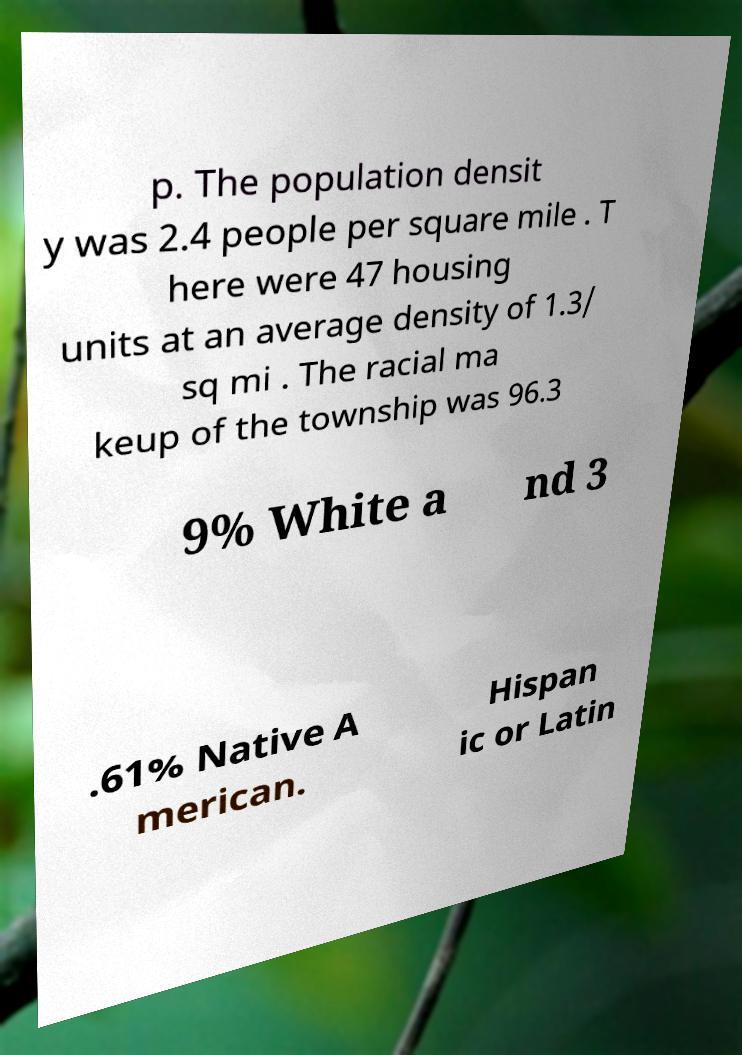Could you extract and type out the text from this image? p. The population densit y was 2.4 people per square mile . T here were 47 housing units at an average density of 1.3/ sq mi . The racial ma keup of the township was 96.3 9% White a nd 3 .61% Native A merican. Hispan ic or Latin 